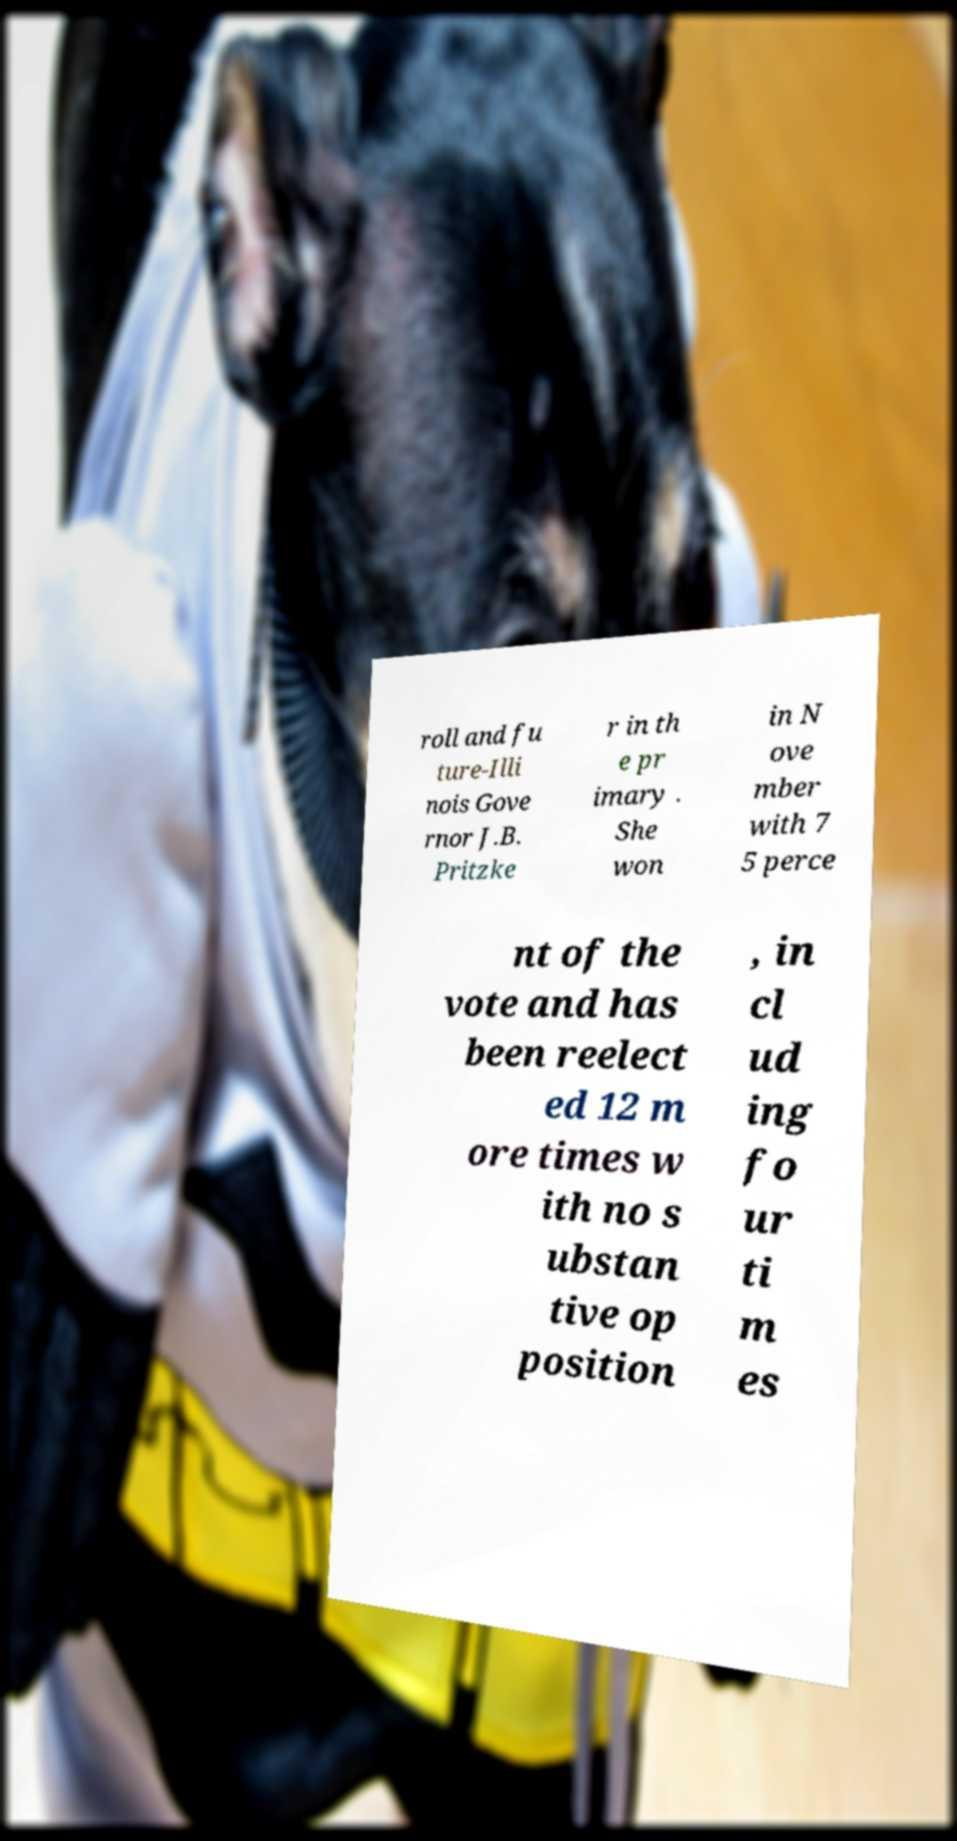For documentation purposes, I need the text within this image transcribed. Could you provide that? roll and fu ture-Illi nois Gove rnor J.B. Pritzke r in th e pr imary . She won in N ove mber with 7 5 perce nt of the vote and has been reelect ed 12 m ore times w ith no s ubstan tive op position , in cl ud ing fo ur ti m es 